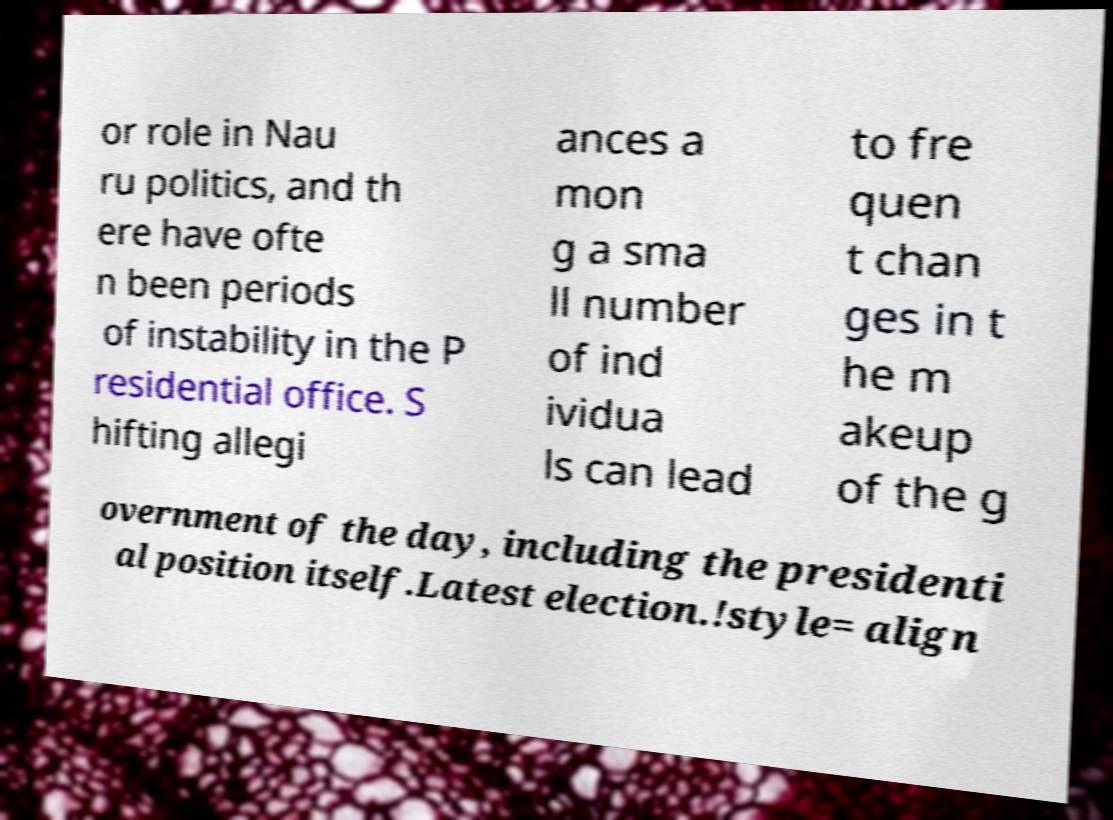Could you assist in decoding the text presented in this image and type it out clearly? or role in Nau ru politics, and th ere have ofte n been periods of instability in the P residential office. S hifting allegi ances a mon g a sma ll number of ind ividua ls can lead to fre quen t chan ges in t he m akeup of the g overnment of the day, including the presidenti al position itself.Latest election.!style= align 